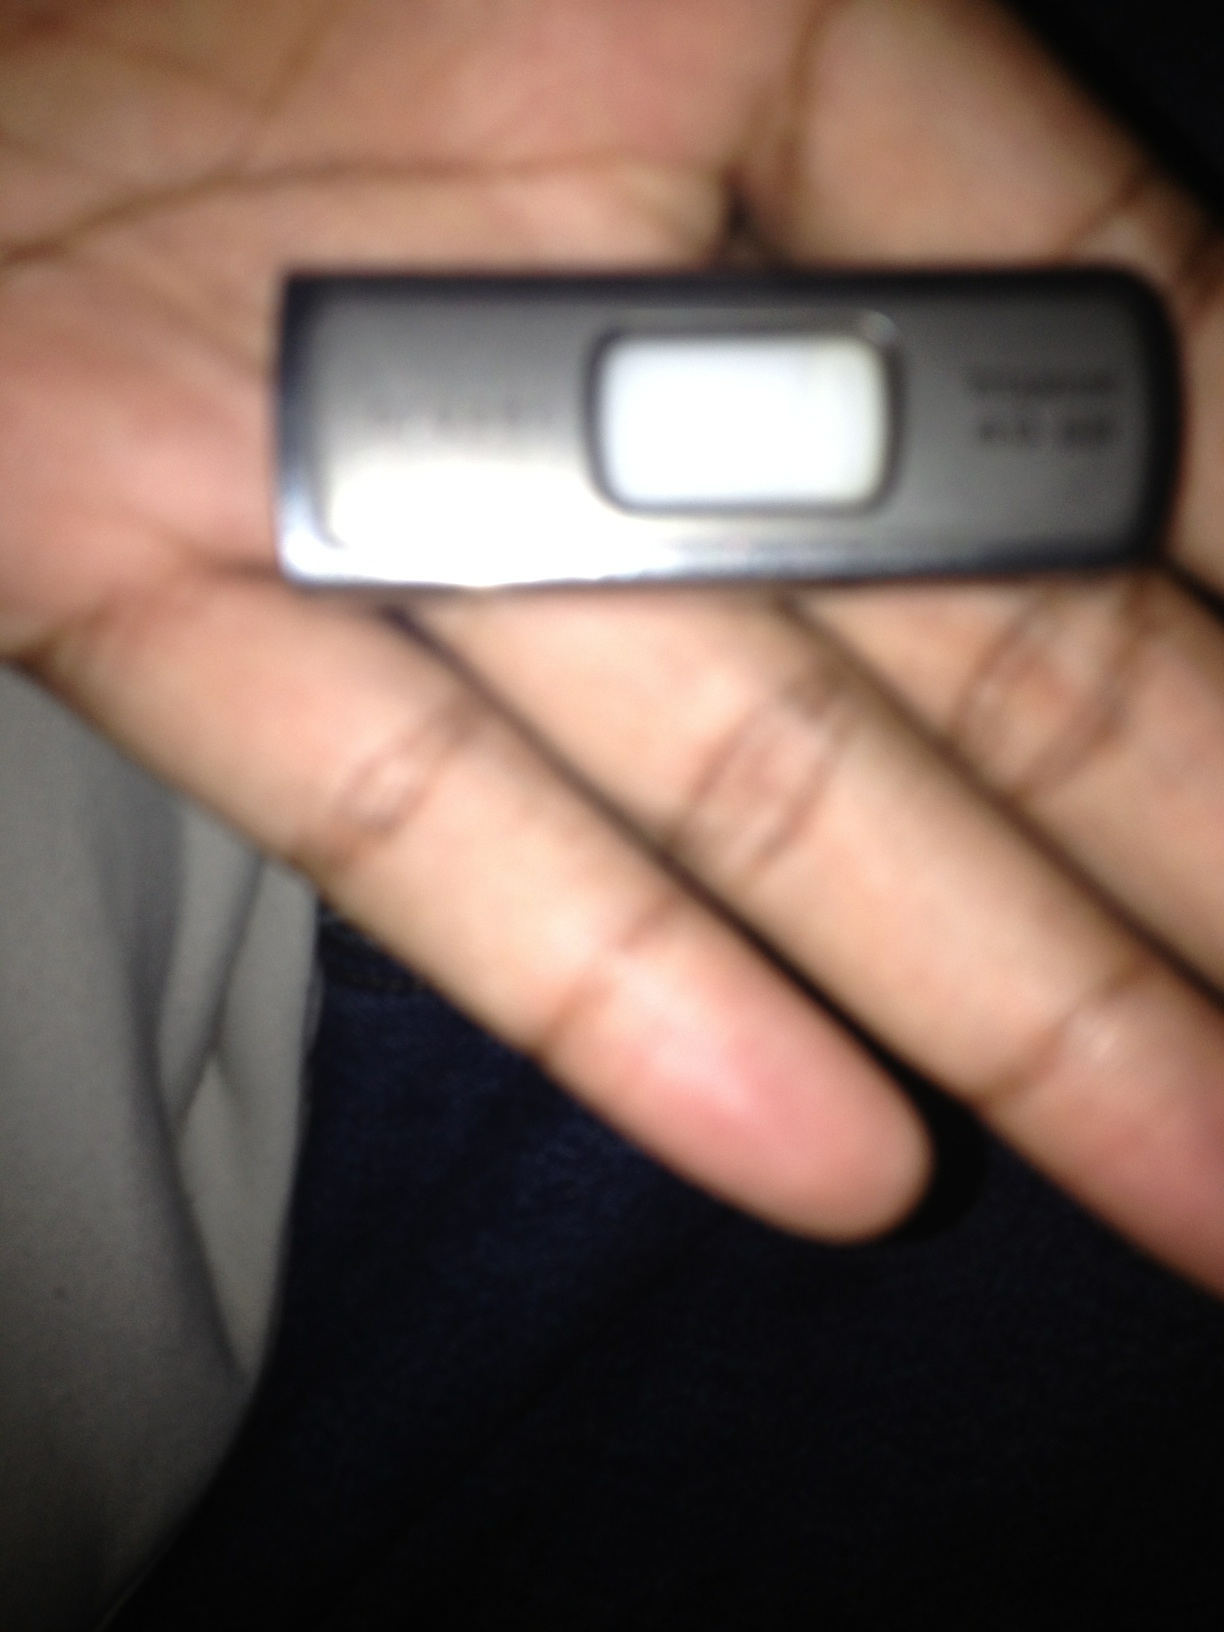What is this? This is a USB flash drive, commonly known as a thumb drive. It is a portable storage device typically used to store and transfer data between computers and other devices. 